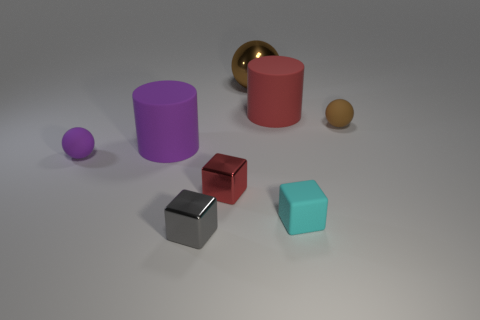What are the different colors of the objects presented in this image? The image showcases objects in various colors: a purple cylinder, a red cylinder, a gold sphere, a maroon cube, a teal cube, and a small yellow sphere. 